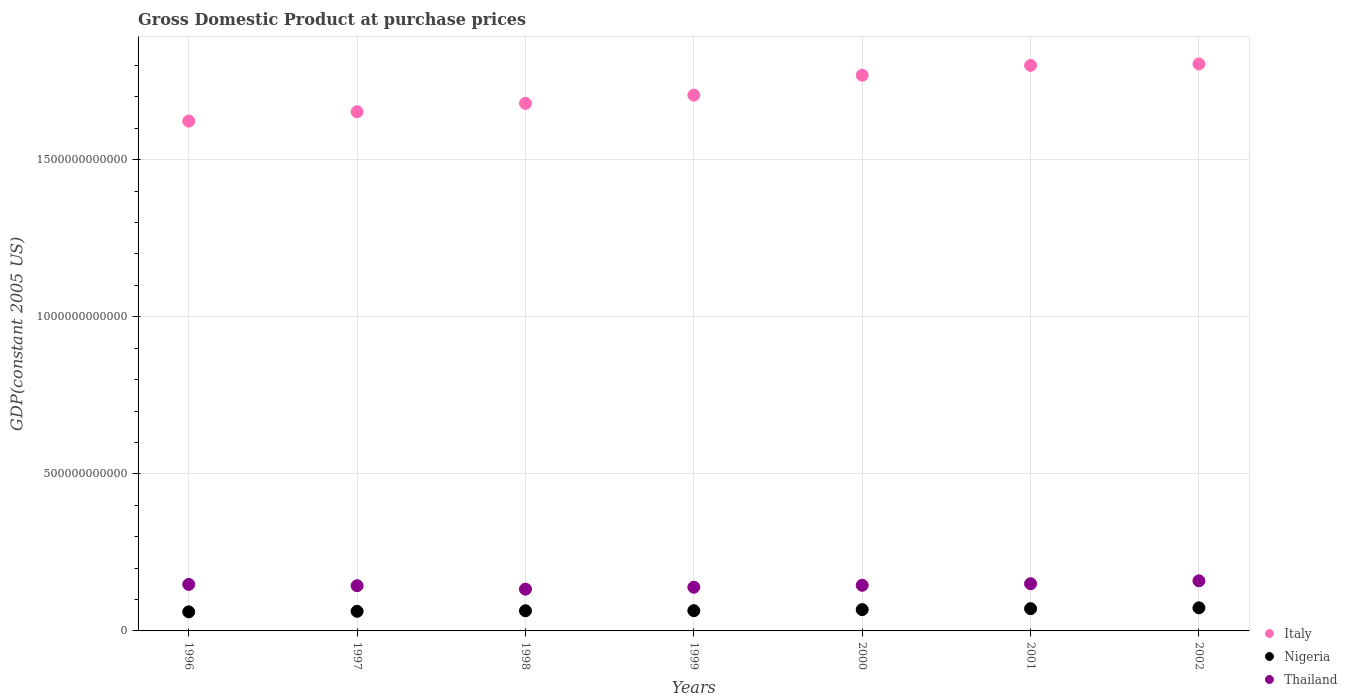Is the number of dotlines equal to the number of legend labels?
Provide a short and direct response. Yes. What is the GDP at purchase prices in Italy in 1997?
Your answer should be very brief. 1.65e+12. Across all years, what is the maximum GDP at purchase prices in Italy?
Offer a very short reply. 1.80e+12. Across all years, what is the minimum GDP at purchase prices in Thailand?
Offer a very short reply. 1.33e+11. In which year was the GDP at purchase prices in Nigeria maximum?
Ensure brevity in your answer.  2002. In which year was the GDP at purchase prices in Nigeria minimum?
Keep it short and to the point. 1996. What is the total GDP at purchase prices in Thailand in the graph?
Your answer should be very brief. 1.02e+12. What is the difference between the GDP at purchase prices in Nigeria in 1999 and that in 2002?
Give a very brief answer. -9.10e+09. What is the difference between the GDP at purchase prices in Thailand in 1998 and the GDP at purchase prices in Italy in 1996?
Your answer should be compact. -1.49e+12. What is the average GDP at purchase prices in Thailand per year?
Make the answer very short. 1.46e+11. In the year 1996, what is the difference between the GDP at purchase prices in Thailand and GDP at purchase prices in Nigeria?
Ensure brevity in your answer.  8.73e+1. In how many years, is the GDP at purchase prices in Nigeria greater than 700000000000 US$?
Offer a terse response. 0. What is the ratio of the GDP at purchase prices in Nigeria in 1996 to that in 1997?
Provide a succinct answer. 0.97. Is the GDP at purchase prices in Thailand in 1996 less than that in 2001?
Ensure brevity in your answer.  Yes. Is the difference between the GDP at purchase prices in Thailand in 1996 and 1998 greater than the difference between the GDP at purchase prices in Nigeria in 1996 and 1998?
Make the answer very short. Yes. What is the difference between the highest and the second highest GDP at purchase prices in Thailand?
Keep it short and to the point. 9.24e+09. What is the difference between the highest and the lowest GDP at purchase prices in Nigeria?
Offer a very short reply. 1.28e+1. Is it the case that in every year, the sum of the GDP at purchase prices in Thailand and GDP at purchase prices in Italy  is greater than the GDP at purchase prices in Nigeria?
Make the answer very short. Yes. Is the GDP at purchase prices in Thailand strictly greater than the GDP at purchase prices in Italy over the years?
Offer a very short reply. No. How many years are there in the graph?
Provide a short and direct response. 7. What is the difference between two consecutive major ticks on the Y-axis?
Give a very brief answer. 5.00e+11. Are the values on the major ticks of Y-axis written in scientific E-notation?
Make the answer very short. No. Where does the legend appear in the graph?
Make the answer very short. Bottom right. How many legend labels are there?
Make the answer very short. 3. What is the title of the graph?
Offer a very short reply. Gross Domestic Product at purchase prices. What is the label or title of the Y-axis?
Ensure brevity in your answer.  GDP(constant 2005 US). What is the GDP(constant 2005 US) of Italy in 1996?
Offer a terse response. 1.62e+12. What is the GDP(constant 2005 US) in Nigeria in 1996?
Give a very brief answer. 6.07e+1. What is the GDP(constant 2005 US) of Thailand in 1996?
Ensure brevity in your answer.  1.48e+11. What is the GDP(constant 2005 US) in Italy in 1997?
Give a very brief answer. 1.65e+12. What is the GDP(constant 2005 US) of Nigeria in 1997?
Offer a terse response. 6.24e+1. What is the GDP(constant 2005 US) of Thailand in 1997?
Offer a very short reply. 1.44e+11. What is the GDP(constant 2005 US) of Italy in 1998?
Make the answer very short. 1.68e+12. What is the GDP(constant 2005 US) in Nigeria in 1998?
Ensure brevity in your answer.  6.41e+1. What is the GDP(constant 2005 US) in Thailand in 1998?
Offer a very short reply. 1.33e+11. What is the GDP(constant 2005 US) of Italy in 1999?
Provide a short and direct response. 1.71e+12. What is the GDP(constant 2005 US) in Nigeria in 1999?
Your answer should be compact. 6.44e+1. What is the GDP(constant 2005 US) in Thailand in 1999?
Your answer should be compact. 1.39e+11. What is the GDP(constant 2005 US) of Italy in 2000?
Make the answer very short. 1.77e+12. What is the GDP(constant 2005 US) in Nigeria in 2000?
Offer a terse response. 6.79e+1. What is the GDP(constant 2005 US) in Thailand in 2000?
Keep it short and to the point. 1.45e+11. What is the GDP(constant 2005 US) in Italy in 2001?
Offer a terse response. 1.80e+12. What is the GDP(constant 2005 US) in Nigeria in 2001?
Keep it short and to the point. 7.08e+1. What is the GDP(constant 2005 US) in Thailand in 2001?
Provide a succinct answer. 1.50e+11. What is the GDP(constant 2005 US) in Italy in 2002?
Make the answer very short. 1.80e+12. What is the GDP(constant 2005 US) of Nigeria in 2002?
Make the answer very short. 7.35e+1. What is the GDP(constant 2005 US) in Thailand in 2002?
Offer a terse response. 1.59e+11. Across all years, what is the maximum GDP(constant 2005 US) of Italy?
Offer a terse response. 1.80e+12. Across all years, what is the maximum GDP(constant 2005 US) of Nigeria?
Your response must be concise. 7.35e+1. Across all years, what is the maximum GDP(constant 2005 US) of Thailand?
Your answer should be compact. 1.59e+11. Across all years, what is the minimum GDP(constant 2005 US) in Italy?
Keep it short and to the point. 1.62e+12. Across all years, what is the minimum GDP(constant 2005 US) in Nigeria?
Offer a very short reply. 6.07e+1. Across all years, what is the minimum GDP(constant 2005 US) of Thailand?
Your answer should be very brief. 1.33e+11. What is the total GDP(constant 2005 US) of Italy in the graph?
Your response must be concise. 1.20e+13. What is the total GDP(constant 2005 US) in Nigeria in the graph?
Your response must be concise. 4.64e+11. What is the total GDP(constant 2005 US) in Thailand in the graph?
Your response must be concise. 1.02e+12. What is the difference between the GDP(constant 2005 US) in Italy in 1996 and that in 1997?
Provide a succinct answer. -2.98e+1. What is the difference between the GDP(constant 2005 US) of Nigeria in 1996 and that in 1997?
Give a very brief answer. -1.70e+09. What is the difference between the GDP(constant 2005 US) in Thailand in 1996 and that in 1997?
Ensure brevity in your answer.  4.08e+09. What is the difference between the GDP(constant 2005 US) in Italy in 1996 and that in 1998?
Make the answer very short. -5.65e+1. What is the difference between the GDP(constant 2005 US) of Nigeria in 1996 and that in 1998?
Provide a succinct answer. -3.40e+09. What is the difference between the GDP(constant 2005 US) of Thailand in 1996 and that in 1998?
Keep it short and to the point. 1.51e+1. What is the difference between the GDP(constant 2005 US) of Italy in 1996 and that in 1999?
Make the answer very short. -8.27e+1. What is the difference between the GDP(constant 2005 US) of Nigeria in 1996 and that in 1999?
Your answer should be very brief. -3.70e+09. What is the difference between the GDP(constant 2005 US) in Thailand in 1996 and that in 1999?
Keep it short and to the point. 8.99e+09. What is the difference between the GDP(constant 2005 US) of Italy in 1996 and that in 2000?
Ensure brevity in your answer.  -1.46e+11. What is the difference between the GDP(constant 2005 US) in Nigeria in 1996 and that in 2000?
Your response must be concise. -7.13e+09. What is the difference between the GDP(constant 2005 US) of Thailand in 1996 and that in 2000?
Offer a very short reply. 2.79e+09. What is the difference between the GDP(constant 2005 US) of Italy in 1996 and that in 2001?
Ensure brevity in your answer.  -1.77e+11. What is the difference between the GDP(constant 2005 US) in Nigeria in 1996 and that in 2001?
Keep it short and to the point. -1.01e+1. What is the difference between the GDP(constant 2005 US) in Thailand in 1996 and that in 2001?
Give a very brief answer. -2.21e+09. What is the difference between the GDP(constant 2005 US) of Italy in 1996 and that in 2002?
Offer a terse response. -1.82e+11. What is the difference between the GDP(constant 2005 US) in Nigeria in 1996 and that in 2002?
Your response must be concise. -1.28e+1. What is the difference between the GDP(constant 2005 US) in Thailand in 1996 and that in 2002?
Give a very brief answer. -1.15e+1. What is the difference between the GDP(constant 2005 US) in Italy in 1997 and that in 1998?
Give a very brief answer. -2.67e+1. What is the difference between the GDP(constant 2005 US) of Nigeria in 1997 and that in 1998?
Offer a very short reply. -1.70e+09. What is the difference between the GDP(constant 2005 US) of Thailand in 1997 and that in 1998?
Your answer should be very brief. 1.10e+1. What is the difference between the GDP(constant 2005 US) of Italy in 1997 and that in 1999?
Ensure brevity in your answer.  -5.29e+1. What is the difference between the GDP(constant 2005 US) of Nigeria in 1997 and that in 1999?
Your answer should be very brief. -2.00e+09. What is the difference between the GDP(constant 2005 US) of Thailand in 1997 and that in 1999?
Keep it short and to the point. 4.91e+09. What is the difference between the GDP(constant 2005 US) of Italy in 1997 and that in 2000?
Ensure brevity in your answer.  -1.16e+11. What is the difference between the GDP(constant 2005 US) of Nigeria in 1997 and that in 2000?
Provide a short and direct response. -5.43e+09. What is the difference between the GDP(constant 2005 US) in Thailand in 1997 and that in 2000?
Give a very brief answer. -1.29e+09. What is the difference between the GDP(constant 2005 US) in Italy in 1997 and that in 2001?
Ensure brevity in your answer.  -1.48e+11. What is the difference between the GDP(constant 2005 US) in Nigeria in 1997 and that in 2001?
Offer a terse response. -8.42e+09. What is the difference between the GDP(constant 2005 US) in Thailand in 1997 and that in 2001?
Make the answer very short. -6.29e+09. What is the difference between the GDP(constant 2005 US) in Italy in 1997 and that in 2002?
Ensure brevity in your answer.  -1.52e+11. What is the difference between the GDP(constant 2005 US) in Nigeria in 1997 and that in 2002?
Your answer should be very brief. -1.11e+1. What is the difference between the GDP(constant 2005 US) in Thailand in 1997 and that in 2002?
Keep it short and to the point. -1.55e+1. What is the difference between the GDP(constant 2005 US) of Italy in 1998 and that in 1999?
Your response must be concise. -2.62e+1. What is the difference between the GDP(constant 2005 US) in Nigeria in 1998 and that in 1999?
Offer a very short reply. -3.04e+08. What is the difference between the GDP(constant 2005 US) of Thailand in 1998 and that in 1999?
Ensure brevity in your answer.  -6.08e+09. What is the difference between the GDP(constant 2005 US) in Italy in 1998 and that in 2000?
Offer a terse response. -8.95e+1. What is the difference between the GDP(constant 2005 US) in Nigeria in 1998 and that in 2000?
Ensure brevity in your answer.  -3.73e+09. What is the difference between the GDP(constant 2005 US) of Thailand in 1998 and that in 2000?
Your answer should be very brief. -1.23e+1. What is the difference between the GDP(constant 2005 US) of Italy in 1998 and that in 2001?
Provide a short and direct response. -1.21e+11. What is the difference between the GDP(constant 2005 US) in Nigeria in 1998 and that in 2001?
Your answer should be compact. -6.72e+09. What is the difference between the GDP(constant 2005 US) of Thailand in 1998 and that in 2001?
Give a very brief answer. -1.73e+1. What is the difference between the GDP(constant 2005 US) in Italy in 1998 and that in 2002?
Give a very brief answer. -1.25e+11. What is the difference between the GDP(constant 2005 US) of Nigeria in 1998 and that in 2002?
Give a very brief answer. -9.40e+09. What is the difference between the GDP(constant 2005 US) in Thailand in 1998 and that in 2002?
Your answer should be compact. -2.65e+1. What is the difference between the GDP(constant 2005 US) of Italy in 1999 and that in 2000?
Your answer should be compact. -6.33e+1. What is the difference between the GDP(constant 2005 US) in Nigeria in 1999 and that in 2000?
Your response must be concise. -3.43e+09. What is the difference between the GDP(constant 2005 US) of Thailand in 1999 and that in 2000?
Provide a succinct answer. -6.20e+09. What is the difference between the GDP(constant 2005 US) in Italy in 1999 and that in 2001?
Offer a terse response. -9.46e+1. What is the difference between the GDP(constant 2005 US) of Nigeria in 1999 and that in 2001?
Ensure brevity in your answer.  -6.42e+09. What is the difference between the GDP(constant 2005 US) of Thailand in 1999 and that in 2001?
Give a very brief answer. -1.12e+1. What is the difference between the GDP(constant 2005 US) in Italy in 1999 and that in 2002?
Offer a terse response. -9.92e+1. What is the difference between the GDP(constant 2005 US) in Nigeria in 1999 and that in 2002?
Your answer should be compact. -9.10e+09. What is the difference between the GDP(constant 2005 US) of Thailand in 1999 and that in 2002?
Provide a short and direct response. -2.04e+1. What is the difference between the GDP(constant 2005 US) in Italy in 2000 and that in 2001?
Your answer should be compact. -3.14e+1. What is the difference between the GDP(constant 2005 US) of Nigeria in 2000 and that in 2001?
Provide a short and direct response. -2.99e+09. What is the difference between the GDP(constant 2005 US) of Thailand in 2000 and that in 2001?
Offer a terse response. -5.00e+09. What is the difference between the GDP(constant 2005 US) of Italy in 2000 and that in 2002?
Keep it short and to the point. -3.59e+1. What is the difference between the GDP(constant 2005 US) of Nigeria in 2000 and that in 2002?
Your answer should be very brief. -5.67e+09. What is the difference between the GDP(constant 2005 US) in Thailand in 2000 and that in 2002?
Offer a terse response. -1.42e+1. What is the difference between the GDP(constant 2005 US) in Italy in 2001 and that in 2002?
Offer a very short reply. -4.51e+09. What is the difference between the GDP(constant 2005 US) in Nigeria in 2001 and that in 2002?
Your answer should be very brief. -2.68e+09. What is the difference between the GDP(constant 2005 US) in Thailand in 2001 and that in 2002?
Offer a terse response. -9.24e+09. What is the difference between the GDP(constant 2005 US) of Italy in 1996 and the GDP(constant 2005 US) of Nigeria in 1997?
Keep it short and to the point. 1.56e+12. What is the difference between the GDP(constant 2005 US) in Italy in 1996 and the GDP(constant 2005 US) in Thailand in 1997?
Provide a short and direct response. 1.48e+12. What is the difference between the GDP(constant 2005 US) in Nigeria in 1996 and the GDP(constant 2005 US) in Thailand in 1997?
Ensure brevity in your answer.  -8.32e+1. What is the difference between the GDP(constant 2005 US) of Italy in 1996 and the GDP(constant 2005 US) of Nigeria in 1998?
Offer a very short reply. 1.56e+12. What is the difference between the GDP(constant 2005 US) in Italy in 1996 and the GDP(constant 2005 US) in Thailand in 1998?
Give a very brief answer. 1.49e+12. What is the difference between the GDP(constant 2005 US) of Nigeria in 1996 and the GDP(constant 2005 US) of Thailand in 1998?
Give a very brief answer. -7.22e+1. What is the difference between the GDP(constant 2005 US) in Italy in 1996 and the GDP(constant 2005 US) in Nigeria in 1999?
Provide a short and direct response. 1.56e+12. What is the difference between the GDP(constant 2005 US) in Italy in 1996 and the GDP(constant 2005 US) in Thailand in 1999?
Make the answer very short. 1.48e+12. What is the difference between the GDP(constant 2005 US) in Nigeria in 1996 and the GDP(constant 2005 US) in Thailand in 1999?
Keep it short and to the point. -7.83e+1. What is the difference between the GDP(constant 2005 US) in Italy in 1996 and the GDP(constant 2005 US) in Nigeria in 2000?
Offer a very short reply. 1.55e+12. What is the difference between the GDP(constant 2005 US) in Italy in 1996 and the GDP(constant 2005 US) in Thailand in 2000?
Offer a terse response. 1.48e+12. What is the difference between the GDP(constant 2005 US) in Nigeria in 1996 and the GDP(constant 2005 US) in Thailand in 2000?
Keep it short and to the point. -8.45e+1. What is the difference between the GDP(constant 2005 US) in Italy in 1996 and the GDP(constant 2005 US) in Nigeria in 2001?
Offer a very short reply. 1.55e+12. What is the difference between the GDP(constant 2005 US) of Italy in 1996 and the GDP(constant 2005 US) of Thailand in 2001?
Keep it short and to the point. 1.47e+12. What is the difference between the GDP(constant 2005 US) of Nigeria in 1996 and the GDP(constant 2005 US) of Thailand in 2001?
Provide a succinct answer. -8.95e+1. What is the difference between the GDP(constant 2005 US) in Italy in 1996 and the GDP(constant 2005 US) in Nigeria in 2002?
Provide a succinct answer. 1.55e+12. What is the difference between the GDP(constant 2005 US) of Italy in 1996 and the GDP(constant 2005 US) of Thailand in 2002?
Provide a succinct answer. 1.46e+12. What is the difference between the GDP(constant 2005 US) in Nigeria in 1996 and the GDP(constant 2005 US) in Thailand in 2002?
Offer a very short reply. -9.88e+1. What is the difference between the GDP(constant 2005 US) of Italy in 1997 and the GDP(constant 2005 US) of Nigeria in 1998?
Ensure brevity in your answer.  1.59e+12. What is the difference between the GDP(constant 2005 US) of Italy in 1997 and the GDP(constant 2005 US) of Thailand in 1998?
Provide a succinct answer. 1.52e+12. What is the difference between the GDP(constant 2005 US) of Nigeria in 1997 and the GDP(constant 2005 US) of Thailand in 1998?
Offer a terse response. -7.05e+1. What is the difference between the GDP(constant 2005 US) of Italy in 1997 and the GDP(constant 2005 US) of Nigeria in 1999?
Make the answer very short. 1.59e+12. What is the difference between the GDP(constant 2005 US) of Italy in 1997 and the GDP(constant 2005 US) of Thailand in 1999?
Your answer should be very brief. 1.51e+12. What is the difference between the GDP(constant 2005 US) in Nigeria in 1997 and the GDP(constant 2005 US) in Thailand in 1999?
Give a very brief answer. -7.66e+1. What is the difference between the GDP(constant 2005 US) in Italy in 1997 and the GDP(constant 2005 US) in Nigeria in 2000?
Offer a terse response. 1.58e+12. What is the difference between the GDP(constant 2005 US) of Italy in 1997 and the GDP(constant 2005 US) of Thailand in 2000?
Your response must be concise. 1.51e+12. What is the difference between the GDP(constant 2005 US) of Nigeria in 1997 and the GDP(constant 2005 US) of Thailand in 2000?
Offer a very short reply. -8.28e+1. What is the difference between the GDP(constant 2005 US) in Italy in 1997 and the GDP(constant 2005 US) in Nigeria in 2001?
Provide a succinct answer. 1.58e+12. What is the difference between the GDP(constant 2005 US) of Italy in 1997 and the GDP(constant 2005 US) of Thailand in 2001?
Provide a short and direct response. 1.50e+12. What is the difference between the GDP(constant 2005 US) in Nigeria in 1997 and the GDP(constant 2005 US) in Thailand in 2001?
Give a very brief answer. -8.78e+1. What is the difference between the GDP(constant 2005 US) in Italy in 1997 and the GDP(constant 2005 US) in Nigeria in 2002?
Make the answer very short. 1.58e+12. What is the difference between the GDP(constant 2005 US) of Italy in 1997 and the GDP(constant 2005 US) of Thailand in 2002?
Your response must be concise. 1.49e+12. What is the difference between the GDP(constant 2005 US) in Nigeria in 1997 and the GDP(constant 2005 US) in Thailand in 2002?
Your response must be concise. -9.71e+1. What is the difference between the GDP(constant 2005 US) in Italy in 1998 and the GDP(constant 2005 US) in Nigeria in 1999?
Give a very brief answer. 1.61e+12. What is the difference between the GDP(constant 2005 US) of Italy in 1998 and the GDP(constant 2005 US) of Thailand in 1999?
Provide a succinct answer. 1.54e+12. What is the difference between the GDP(constant 2005 US) of Nigeria in 1998 and the GDP(constant 2005 US) of Thailand in 1999?
Your response must be concise. -7.49e+1. What is the difference between the GDP(constant 2005 US) of Italy in 1998 and the GDP(constant 2005 US) of Nigeria in 2000?
Give a very brief answer. 1.61e+12. What is the difference between the GDP(constant 2005 US) of Italy in 1998 and the GDP(constant 2005 US) of Thailand in 2000?
Ensure brevity in your answer.  1.53e+12. What is the difference between the GDP(constant 2005 US) of Nigeria in 1998 and the GDP(constant 2005 US) of Thailand in 2000?
Make the answer very short. -8.11e+1. What is the difference between the GDP(constant 2005 US) of Italy in 1998 and the GDP(constant 2005 US) of Nigeria in 2001?
Ensure brevity in your answer.  1.61e+12. What is the difference between the GDP(constant 2005 US) of Italy in 1998 and the GDP(constant 2005 US) of Thailand in 2001?
Your answer should be very brief. 1.53e+12. What is the difference between the GDP(constant 2005 US) of Nigeria in 1998 and the GDP(constant 2005 US) of Thailand in 2001?
Make the answer very short. -8.61e+1. What is the difference between the GDP(constant 2005 US) of Italy in 1998 and the GDP(constant 2005 US) of Nigeria in 2002?
Your answer should be compact. 1.61e+12. What is the difference between the GDP(constant 2005 US) of Italy in 1998 and the GDP(constant 2005 US) of Thailand in 2002?
Offer a terse response. 1.52e+12. What is the difference between the GDP(constant 2005 US) of Nigeria in 1998 and the GDP(constant 2005 US) of Thailand in 2002?
Offer a terse response. -9.54e+1. What is the difference between the GDP(constant 2005 US) in Italy in 1999 and the GDP(constant 2005 US) in Nigeria in 2000?
Your answer should be compact. 1.64e+12. What is the difference between the GDP(constant 2005 US) of Italy in 1999 and the GDP(constant 2005 US) of Thailand in 2000?
Ensure brevity in your answer.  1.56e+12. What is the difference between the GDP(constant 2005 US) of Nigeria in 1999 and the GDP(constant 2005 US) of Thailand in 2000?
Make the answer very short. -8.08e+1. What is the difference between the GDP(constant 2005 US) of Italy in 1999 and the GDP(constant 2005 US) of Nigeria in 2001?
Provide a succinct answer. 1.63e+12. What is the difference between the GDP(constant 2005 US) in Italy in 1999 and the GDP(constant 2005 US) in Thailand in 2001?
Give a very brief answer. 1.56e+12. What is the difference between the GDP(constant 2005 US) in Nigeria in 1999 and the GDP(constant 2005 US) in Thailand in 2001?
Offer a terse response. -8.58e+1. What is the difference between the GDP(constant 2005 US) in Italy in 1999 and the GDP(constant 2005 US) in Nigeria in 2002?
Offer a terse response. 1.63e+12. What is the difference between the GDP(constant 2005 US) in Italy in 1999 and the GDP(constant 2005 US) in Thailand in 2002?
Your answer should be compact. 1.55e+12. What is the difference between the GDP(constant 2005 US) of Nigeria in 1999 and the GDP(constant 2005 US) of Thailand in 2002?
Make the answer very short. -9.51e+1. What is the difference between the GDP(constant 2005 US) in Italy in 2000 and the GDP(constant 2005 US) in Nigeria in 2001?
Provide a short and direct response. 1.70e+12. What is the difference between the GDP(constant 2005 US) of Italy in 2000 and the GDP(constant 2005 US) of Thailand in 2001?
Provide a short and direct response. 1.62e+12. What is the difference between the GDP(constant 2005 US) in Nigeria in 2000 and the GDP(constant 2005 US) in Thailand in 2001?
Ensure brevity in your answer.  -8.24e+1. What is the difference between the GDP(constant 2005 US) in Italy in 2000 and the GDP(constant 2005 US) in Nigeria in 2002?
Offer a very short reply. 1.70e+12. What is the difference between the GDP(constant 2005 US) in Italy in 2000 and the GDP(constant 2005 US) in Thailand in 2002?
Keep it short and to the point. 1.61e+12. What is the difference between the GDP(constant 2005 US) of Nigeria in 2000 and the GDP(constant 2005 US) of Thailand in 2002?
Your answer should be very brief. -9.16e+1. What is the difference between the GDP(constant 2005 US) of Italy in 2001 and the GDP(constant 2005 US) of Nigeria in 2002?
Offer a very short reply. 1.73e+12. What is the difference between the GDP(constant 2005 US) of Italy in 2001 and the GDP(constant 2005 US) of Thailand in 2002?
Ensure brevity in your answer.  1.64e+12. What is the difference between the GDP(constant 2005 US) in Nigeria in 2001 and the GDP(constant 2005 US) in Thailand in 2002?
Provide a short and direct response. -8.86e+1. What is the average GDP(constant 2005 US) of Italy per year?
Offer a very short reply. 1.72e+12. What is the average GDP(constant 2005 US) in Nigeria per year?
Your answer should be very brief. 6.63e+1. What is the average GDP(constant 2005 US) of Thailand per year?
Make the answer very short. 1.46e+11. In the year 1996, what is the difference between the GDP(constant 2005 US) in Italy and GDP(constant 2005 US) in Nigeria?
Ensure brevity in your answer.  1.56e+12. In the year 1996, what is the difference between the GDP(constant 2005 US) of Italy and GDP(constant 2005 US) of Thailand?
Your answer should be very brief. 1.47e+12. In the year 1996, what is the difference between the GDP(constant 2005 US) of Nigeria and GDP(constant 2005 US) of Thailand?
Make the answer very short. -8.73e+1. In the year 1997, what is the difference between the GDP(constant 2005 US) of Italy and GDP(constant 2005 US) of Nigeria?
Provide a succinct answer. 1.59e+12. In the year 1997, what is the difference between the GDP(constant 2005 US) of Italy and GDP(constant 2005 US) of Thailand?
Make the answer very short. 1.51e+12. In the year 1997, what is the difference between the GDP(constant 2005 US) of Nigeria and GDP(constant 2005 US) of Thailand?
Offer a terse response. -8.15e+1. In the year 1998, what is the difference between the GDP(constant 2005 US) in Italy and GDP(constant 2005 US) in Nigeria?
Offer a terse response. 1.62e+12. In the year 1998, what is the difference between the GDP(constant 2005 US) of Italy and GDP(constant 2005 US) of Thailand?
Your response must be concise. 1.55e+12. In the year 1998, what is the difference between the GDP(constant 2005 US) in Nigeria and GDP(constant 2005 US) in Thailand?
Your answer should be very brief. -6.89e+1. In the year 1999, what is the difference between the GDP(constant 2005 US) of Italy and GDP(constant 2005 US) of Nigeria?
Give a very brief answer. 1.64e+12. In the year 1999, what is the difference between the GDP(constant 2005 US) in Italy and GDP(constant 2005 US) in Thailand?
Your response must be concise. 1.57e+12. In the year 1999, what is the difference between the GDP(constant 2005 US) in Nigeria and GDP(constant 2005 US) in Thailand?
Provide a succinct answer. -7.46e+1. In the year 2000, what is the difference between the GDP(constant 2005 US) of Italy and GDP(constant 2005 US) of Nigeria?
Your answer should be very brief. 1.70e+12. In the year 2000, what is the difference between the GDP(constant 2005 US) in Italy and GDP(constant 2005 US) in Thailand?
Ensure brevity in your answer.  1.62e+12. In the year 2000, what is the difference between the GDP(constant 2005 US) of Nigeria and GDP(constant 2005 US) of Thailand?
Keep it short and to the point. -7.74e+1. In the year 2001, what is the difference between the GDP(constant 2005 US) in Italy and GDP(constant 2005 US) in Nigeria?
Offer a terse response. 1.73e+12. In the year 2001, what is the difference between the GDP(constant 2005 US) in Italy and GDP(constant 2005 US) in Thailand?
Your response must be concise. 1.65e+12. In the year 2001, what is the difference between the GDP(constant 2005 US) in Nigeria and GDP(constant 2005 US) in Thailand?
Your answer should be very brief. -7.94e+1. In the year 2002, what is the difference between the GDP(constant 2005 US) of Italy and GDP(constant 2005 US) of Nigeria?
Provide a succinct answer. 1.73e+12. In the year 2002, what is the difference between the GDP(constant 2005 US) of Italy and GDP(constant 2005 US) of Thailand?
Your answer should be very brief. 1.65e+12. In the year 2002, what is the difference between the GDP(constant 2005 US) of Nigeria and GDP(constant 2005 US) of Thailand?
Keep it short and to the point. -8.60e+1. What is the ratio of the GDP(constant 2005 US) of Italy in 1996 to that in 1997?
Provide a succinct answer. 0.98. What is the ratio of the GDP(constant 2005 US) of Nigeria in 1996 to that in 1997?
Give a very brief answer. 0.97. What is the ratio of the GDP(constant 2005 US) in Thailand in 1996 to that in 1997?
Offer a terse response. 1.03. What is the ratio of the GDP(constant 2005 US) of Italy in 1996 to that in 1998?
Provide a succinct answer. 0.97. What is the ratio of the GDP(constant 2005 US) in Nigeria in 1996 to that in 1998?
Your answer should be very brief. 0.95. What is the ratio of the GDP(constant 2005 US) in Thailand in 1996 to that in 1998?
Make the answer very short. 1.11. What is the ratio of the GDP(constant 2005 US) of Italy in 1996 to that in 1999?
Make the answer very short. 0.95. What is the ratio of the GDP(constant 2005 US) in Nigeria in 1996 to that in 1999?
Make the answer very short. 0.94. What is the ratio of the GDP(constant 2005 US) in Thailand in 1996 to that in 1999?
Give a very brief answer. 1.06. What is the ratio of the GDP(constant 2005 US) of Italy in 1996 to that in 2000?
Keep it short and to the point. 0.92. What is the ratio of the GDP(constant 2005 US) in Nigeria in 1996 to that in 2000?
Give a very brief answer. 0.9. What is the ratio of the GDP(constant 2005 US) of Thailand in 1996 to that in 2000?
Ensure brevity in your answer.  1.02. What is the ratio of the GDP(constant 2005 US) in Italy in 1996 to that in 2001?
Your answer should be compact. 0.9. What is the ratio of the GDP(constant 2005 US) of Nigeria in 1996 to that in 2001?
Your response must be concise. 0.86. What is the ratio of the GDP(constant 2005 US) of Italy in 1996 to that in 2002?
Your answer should be very brief. 0.9. What is the ratio of the GDP(constant 2005 US) of Nigeria in 1996 to that in 2002?
Make the answer very short. 0.83. What is the ratio of the GDP(constant 2005 US) of Thailand in 1996 to that in 2002?
Give a very brief answer. 0.93. What is the ratio of the GDP(constant 2005 US) in Italy in 1997 to that in 1998?
Provide a short and direct response. 0.98. What is the ratio of the GDP(constant 2005 US) of Nigeria in 1997 to that in 1998?
Provide a succinct answer. 0.97. What is the ratio of the GDP(constant 2005 US) of Thailand in 1997 to that in 1998?
Give a very brief answer. 1.08. What is the ratio of the GDP(constant 2005 US) of Thailand in 1997 to that in 1999?
Ensure brevity in your answer.  1.04. What is the ratio of the GDP(constant 2005 US) in Italy in 1997 to that in 2000?
Give a very brief answer. 0.93. What is the ratio of the GDP(constant 2005 US) of Nigeria in 1997 to that in 2000?
Ensure brevity in your answer.  0.92. What is the ratio of the GDP(constant 2005 US) of Thailand in 1997 to that in 2000?
Your answer should be compact. 0.99. What is the ratio of the GDP(constant 2005 US) in Italy in 1997 to that in 2001?
Ensure brevity in your answer.  0.92. What is the ratio of the GDP(constant 2005 US) in Nigeria in 1997 to that in 2001?
Offer a terse response. 0.88. What is the ratio of the GDP(constant 2005 US) of Thailand in 1997 to that in 2001?
Keep it short and to the point. 0.96. What is the ratio of the GDP(constant 2005 US) of Italy in 1997 to that in 2002?
Your answer should be very brief. 0.92. What is the ratio of the GDP(constant 2005 US) of Nigeria in 1997 to that in 2002?
Provide a short and direct response. 0.85. What is the ratio of the GDP(constant 2005 US) in Thailand in 1997 to that in 2002?
Make the answer very short. 0.9. What is the ratio of the GDP(constant 2005 US) in Italy in 1998 to that in 1999?
Offer a terse response. 0.98. What is the ratio of the GDP(constant 2005 US) in Thailand in 1998 to that in 1999?
Provide a succinct answer. 0.96. What is the ratio of the GDP(constant 2005 US) of Italy in 1998 to that in 2000?
Offer a terse response. 0.95. What is the ratio of the GDP(constant 2005 US) in Nigeria in 1998 to that in 2000?
Provide a short and direct response. 0.94. What is the ratio of the GDP(constant 2005 US) of Thailand in 1998 to that in 2000?
Make the answer very short. 0.92. What is the ratio of the GDP(constant 2005 US) in Italy in 1998 to that in 2001?
Provide a succinct answer. 0.93. What is the ratio of the GDP(constant 2005 US) in Nigeria in 1998 to that in 2001?
Provide a short and direct response. 0.91. What is the ratio of the GDP(constant 2005 US) in Thailand in 1998 to that in 2001?
Give a very brief answer. 0.89. What is the ratio of the GDP(constant 2005 US) in Italy in 1998 to that in 2002?
Provide a short and direct response. 0.93. What is the ratio of the GDP(constant 2005 US) in Nigeria in 1998 to that in 2002?
Keep it short and to the point. 0.87. What is the ratio of the GDP(constant 2005 US) in Thailand in 1998 to that in 2002?
Your answer should be very brief. 0.83. What is the ratio of the GDP(constant 2005 US) of Italy in 1999 to that in 2000?
Offer a terse response. 0.96. What is the ratio of the GDP(constant 2005 US) of Nigeria in 1999 to that in 2000?
Your response must be concise. 0.95. What is the ratio of the GDP(constant 2005 US) in Thailand in 1999 to that in 2000?
Your answer should be compact. 0.96. What is the ratio of the GDP(constant 2005 US) of Italy in 1999 to that in 2001?
Keep it short and to the point. 0.95. What is the ratio of the GDP(constant 2005 US) of Nigeria in 1999 to that in 2001?
Your answer should be compact. 0.91. What is the ratio of the GDP(constant 2005 US) in Thailand in 1999 to that in 2001?
Your answer should be compact. 0.93. What is the ratio of the GDP(constant 2005 US) of Italy in 1999 to that in 2002?
Provide a short and direct response. 0.95. What is the ratio of the GDP(constant 2005 US) in Nigeria in 1999 to that in 2002?
Keep it short and to the point. 0.88. What is the ratio of the GDP(constant 2005 US) in Thailand in 1999 to that in 2002?
Provide a succinct answer. 0.87. What is the ratio of the GDP(constant 2005 US) in Italy in 2000 to that in 2001?
Your response must be concise. 0.98. What is the ratio of the GDP(constant 2005 US) in Nigeria in 2000 to that in 2001?
Offer a very short reply. 0.96. What is the ratio of the GDP(constant 2005 US) of Thailand in 2000 to that in 2001?
Your answer should be compact. 0.97. What is the ratio of the GDP(constant 2005 US) in Italy in 2000 to that in 2002?
Your answer should be compact. 0.98. What is the ratio of the GDP(constant 2005 US) in Nigeria in 2000 to that in 2002?
Offer a very short reply. 0.92. What is the ratio of the GDP(constant 2005 US) in Thailand in 2000 to that in 2002?
Make the answer very short. 0.91. What is the ratio of the GDP(constant 2005 US) in Nigeria in 2001 to that in 2002?
Give a very brief answer. 0.96. What is the ratio of the GDP(constant 2005 US) of Thailand in 2001 to that in 2002?
Your answer should be compact. 0.94. What is the difference between the highest and the second highest GDP(constant 2005 US) in Italy?
Make the answer very short. 4.51e+09. What is the difference between the highest and the second highest GDP(constant 2005 US) in Nigeria?
Offer a very short reply. 2.68e+09. What is the difference between the highest and the second highest GDP(constant 2005 US) in Thailand?
Ensure brevity in your answer.  9.24e+09. What is the difference between the highest and the lowest GDP(constant 2005 US) of Italy?
Offer a very short reply. 1.82e+11. What is the difference between the highest and the lowest GDP(constant 2005 US) of Nigeria?
Provide a short and direct response. 1.28e+1. What is the difference between the highest and the lowest GDP(constant 2005 US) in Thailand?
Ensure brevity in your answer.  2.65e+1. 